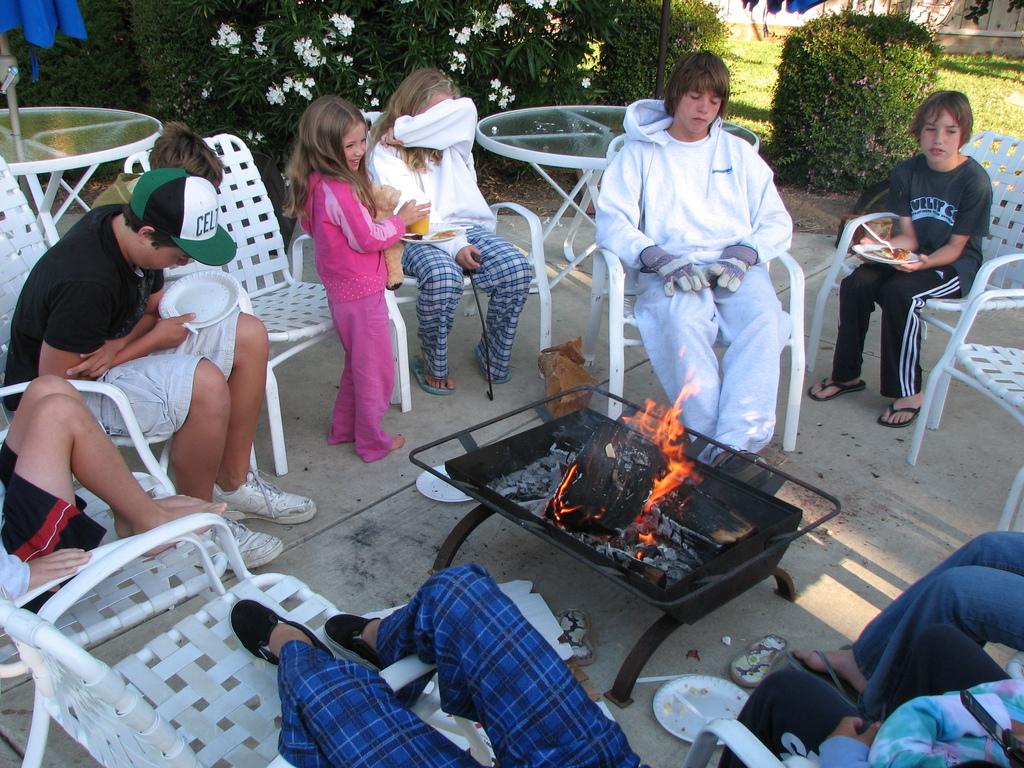What is the first letter on the guys hat?
Make the answer very short. C. 